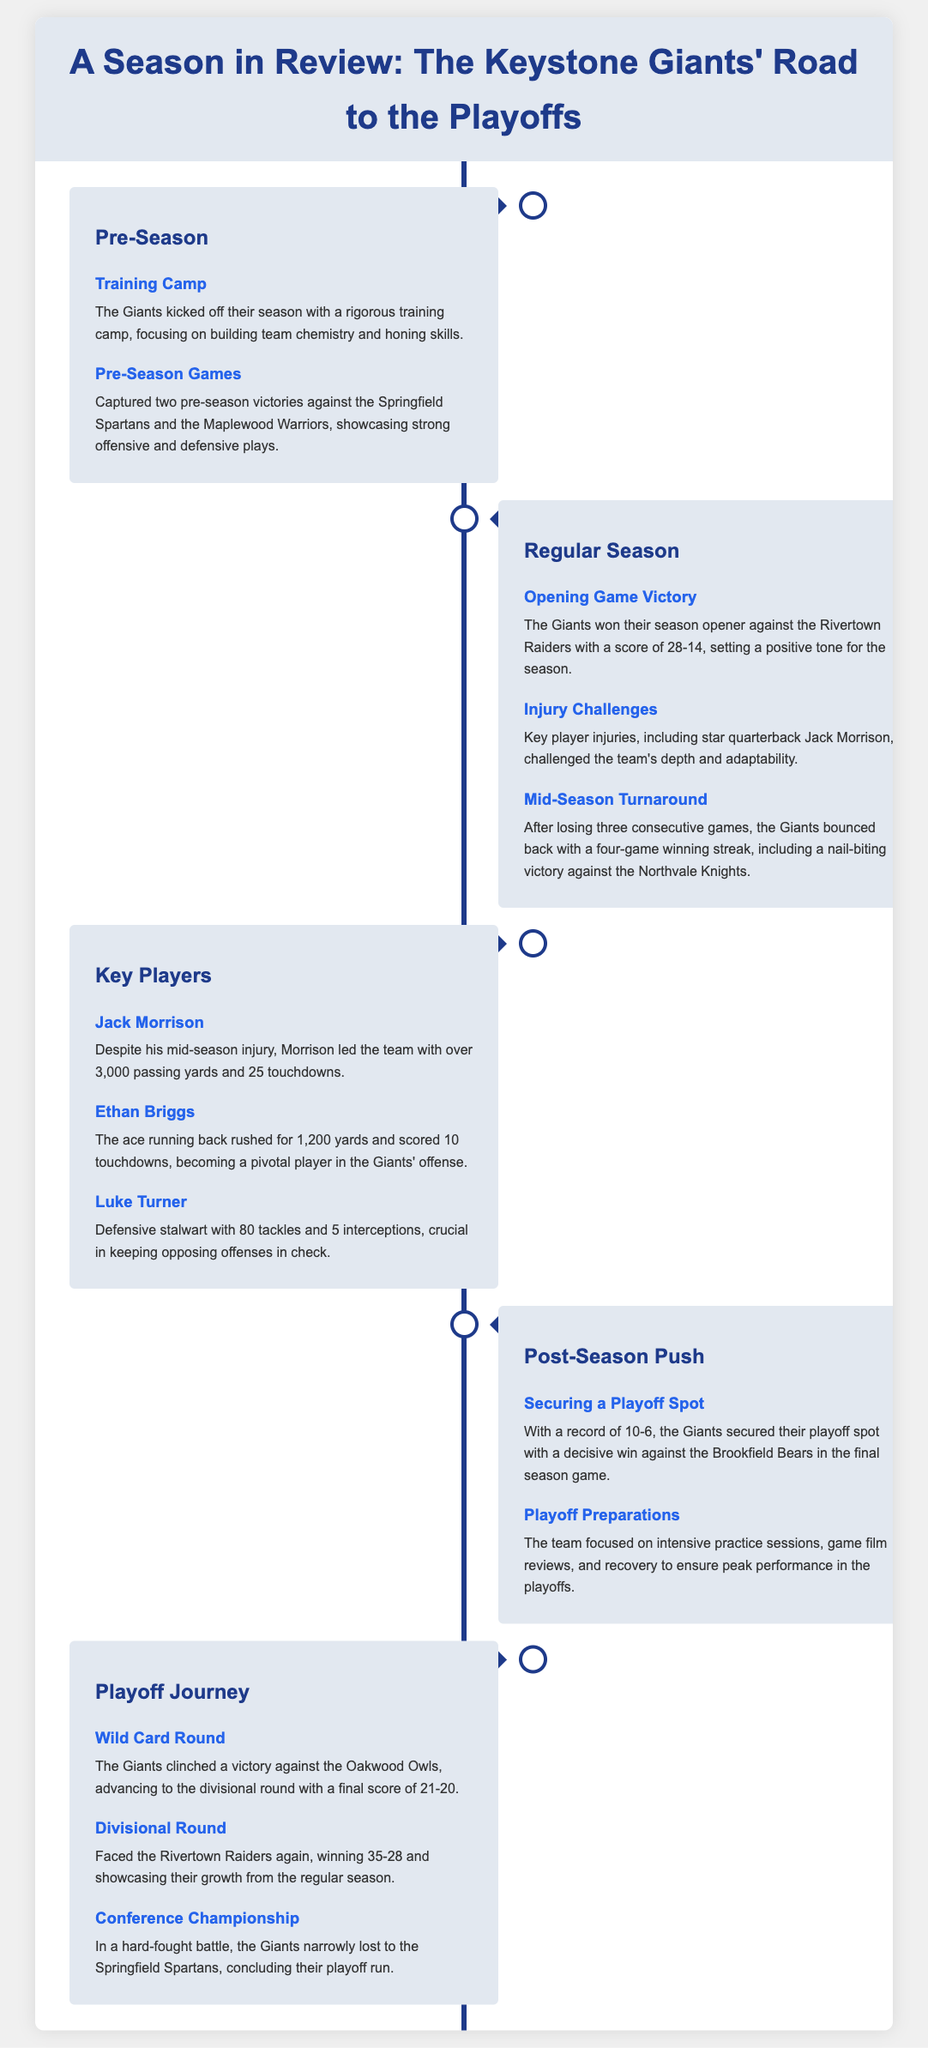What was the record of the Giants at the end of the regular season? The document states that the Giants secured a playoff spot with a record of 10-6.
Answer: 10-6 Who was the leading quarterback for the Giants? The document mentions Jack Morrison as the player who led the team in passing yards and touchdowns.
Answer: Jack Morrison What significant event happened in the mid-season? The timeline notes that the Giants lost three consecutive games before bouncing back.
Answer: Lost three consecutive games How many touchdowns did Ethan Briggs score? According to the document, Ethan Briggs scored 10 touchdowns during the season.
Answer: 10 touchdowns What was the final score of the Wild Card Round game? The document specifies that the Giants' victory against the Oakwood Owls was by a score of 21-20.
Answer: 21-20 What preparation focus did the team have for the playoffs? The document states that the team focused on intensive practice sessions, game film reviews, and recovery.
Answer: Intensive practice sessions In which stage did the Giants face the Rivertown Raiders in the playoffs? The document notes that the Giants faced the Rivertown Raiders in the Divisional Round.
Answer: Divisional Round Who was the defensive standout for the Giants? The document highlights Luke Turner as a defensive stalwart with significant statistics.
Answer: Luke Turner What was the outcome of the Conference Championship? The document concludes with the Giants losing to the Springfield Spartans.
Answer: Narrowly lost to the Springfield Spartans 